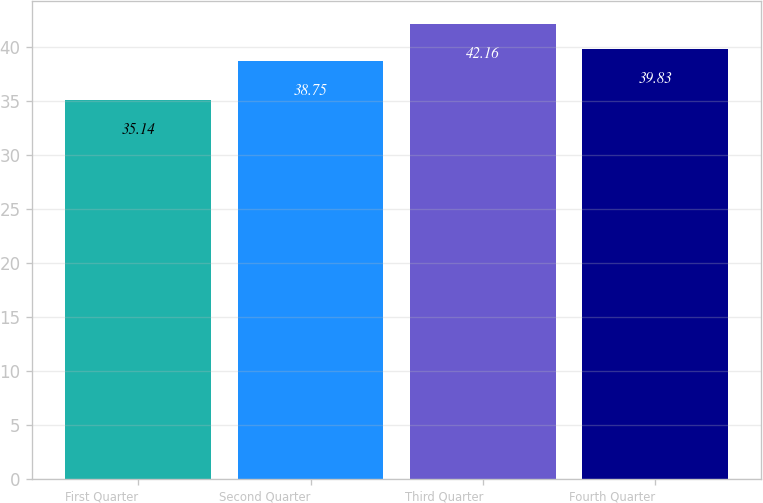<chart> <loc_0><loc_0><loc_500><loc_500><bar_chart><fcel>First Quarter<fcel>Second Quarter<fcel>Third Quarter<fcel>Fourth Quarter<nl><fcel>35.14<fcel>38.75<fcel>42.16<fcel>39.83<nl></chart> 